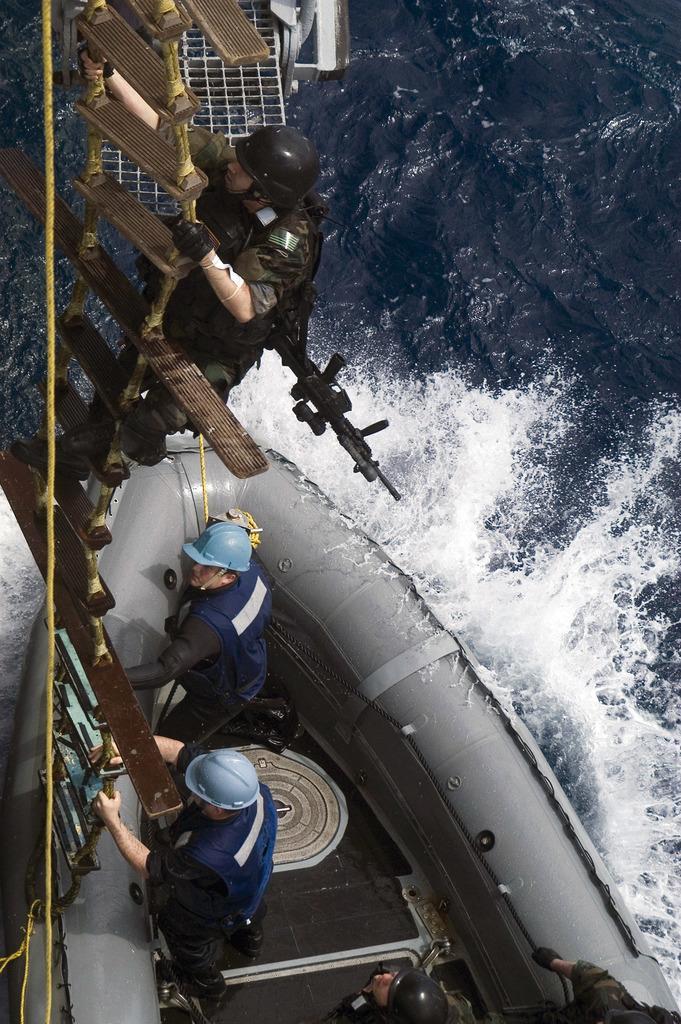In one or two sentences, can you explain what this image depicts? In this image I can see few persons on a boat. There is a person climbing the rope ladder. There is water and there are some other objects. 